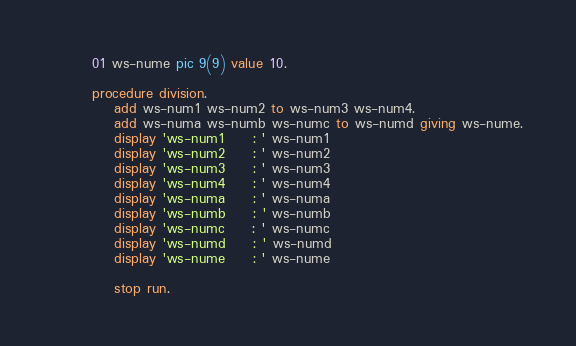Convert code to text. <code><loc_0><loc_0><loc_500><loc_500><_COBOL_>       01 ws-nume pic 9(9) value 10.

       procedure division.
           add ws-num1 ws-num2 to ws-num3 ws-num4.
           add ws-numa ws-numb ws-numc to ws-numd giving ws-nume.
           display 'ws-num1     : ' ws-num1
           display 'ws-num2     : ' ws-num2
           display 'ws-num3     : ' ws-num3
           display 'ws-num4     : ' ws-num4
           display 'ws-numa     : ' ws-numa
           display 'ws-numb     : ' ws-numb
           display 'ws-numc     : ' ws-numc
           display 'ws-numd     : ' ws-numd
           display 'ws-nume     : ' ws-nume

           stop run.

</code> 